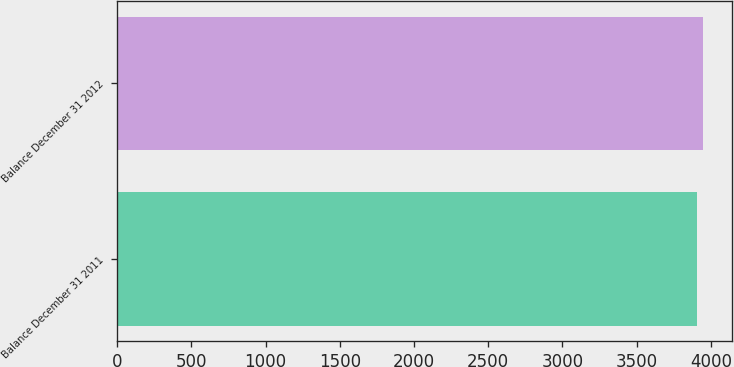<chart> <loc_0><loc_0><loc_500><loc_500><bar_chart><fcel>Balance December 31 2011<fcel>Balance December 31 2012<nl><fcel>3908.5<fcel>3949<nl></chart> 